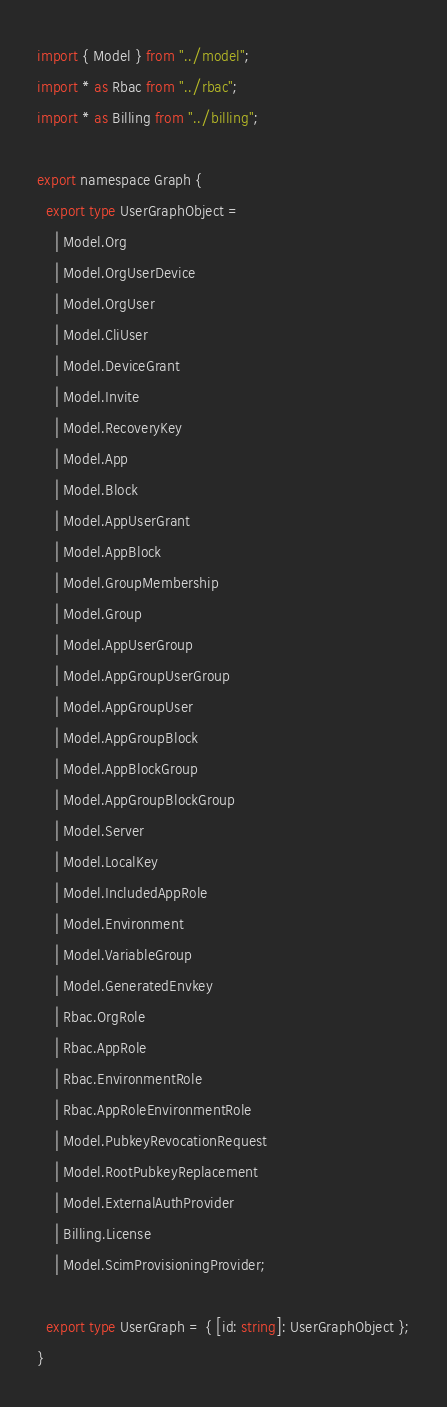Convert code to text. <code><loc_0><loc_0><loc_500><loc_500><_TypeScript_>import { Model } from "../model";
import * as Rbac from "../rbac";
import * as Billing from "../billing";

export namespace Graph {
  export type UserGraphObject =
    | Model.Org
    | Model.OrgUserDevice
    | Model.OrgUser
    | Model.CliUser
    | Model.DeviceGrant
    | Model.Invite
    | Model.RecoveryKey
    | Model.App
    | Model.Block
    | Model.AppUserGrant
    | Model.AppBlock
    | Model.GroupMembership
    | Model.Group
    | Model.AppUserGroup
    | Model.AppGroupUserGroup
    | Model.AppGroupUser
    | Model.AppGroupBlock
    | Model.AppBlockGroup
    | Model.AppGroupBlockGroup
    | Model.Server
    | Model.LocalKey
    | Model.IncludedAppRole
    | Model.Environment
    | Model.VariableGroup
    | Model.GeneratedEnvkey
    | Rbac.OrgRole
    | Rbac.AppRole
    | Rbac.EnvironmentRole
    | Rbac.AppRoleEnvironmentRole
    | Model.PubkeyRevocationRequest
    | Model.RootPubkeyReplacement
    | Model.ExternalAuthProvider
    | Billing.License
    | Model.ScimProvisioningProvider;

  export type UserGraph = { [id: string]: UserGraphObject };
}
</code> 